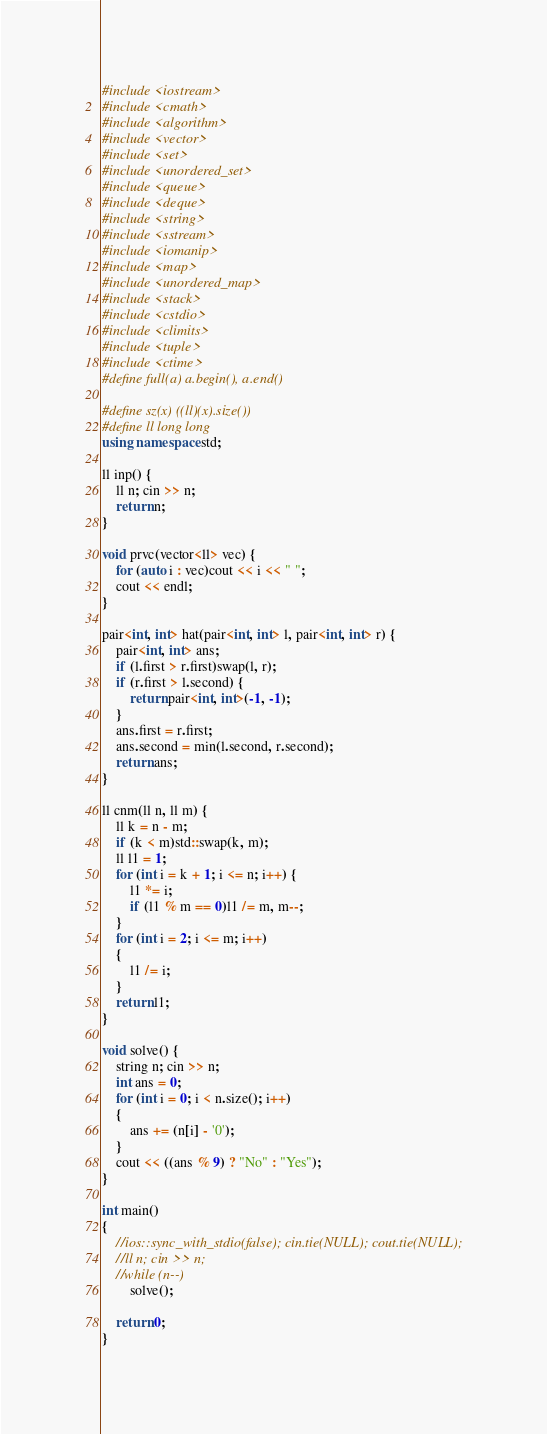<code> <loc_0><loc_0><loc_500><loc_500><_C++_>#include <iostream>
#include <cmath>
#include <algorithm>
#include <vector>
#include <set>
#include <unordered_set>
#include <queue>
#include <deque>
#include <string>
#include <sstream>
#include <iomanip>
#include <map>
#include <unordered_map>
#include <stack>
#include <cstdio>
#include <climits>
#include <tuple>
#include <ctime> 
#define full(a) a.begin(), a.end()

#define sz(x) ((ll)(x).size())
#define ll long long
using namespace std;

ll inp() {
    ll n; cin >> n;
    return n;
}

void prvc(vector<ll> vec) {
    for (auto i : vec)cout << i << " ";
    cout << endl;
}

pair<int, int> hat(pair<int, int> l, pair<int, int> r) {
    pair<int, int> ans;
    if (l.first > r.first)swap(l, r);
    if (r.first > l.second) {
        return pair<int, int>(-1, -1);
    }
    ans.first = r.first;
    ans.second = min(l.second, r.second);
    return ans;
}

ll cnm(ll n, ll m) {
    ll k = n - m;
    if (k < m)std::swap(k, m);
    ll l1 = 1;
    for (int i = k + 1; i <= n; i++) {
        l1 *= i;
        if (l1 % m == 0)l1 /= m, m--;
    }
    for (int i = 2; i <= m; i++)
    {
        l1 /= i;
    }
    return l1;
}

void solve() {
    string n; cin >> n;
    int ans = 0;
    for (int i = 0; i < n.size(); i++)
    {
        ans += (n[i] - '0');
    }
    cout << ((ans % 9) ? "No" : "Yes");
}

int main()
{
    //ios::sync_with_stdio(false); cin.tie(NULL); cout.tie(NULL);
    //ll n; cin >> n;
    //while (n--)
        solve();

    return 0;
}</code> 